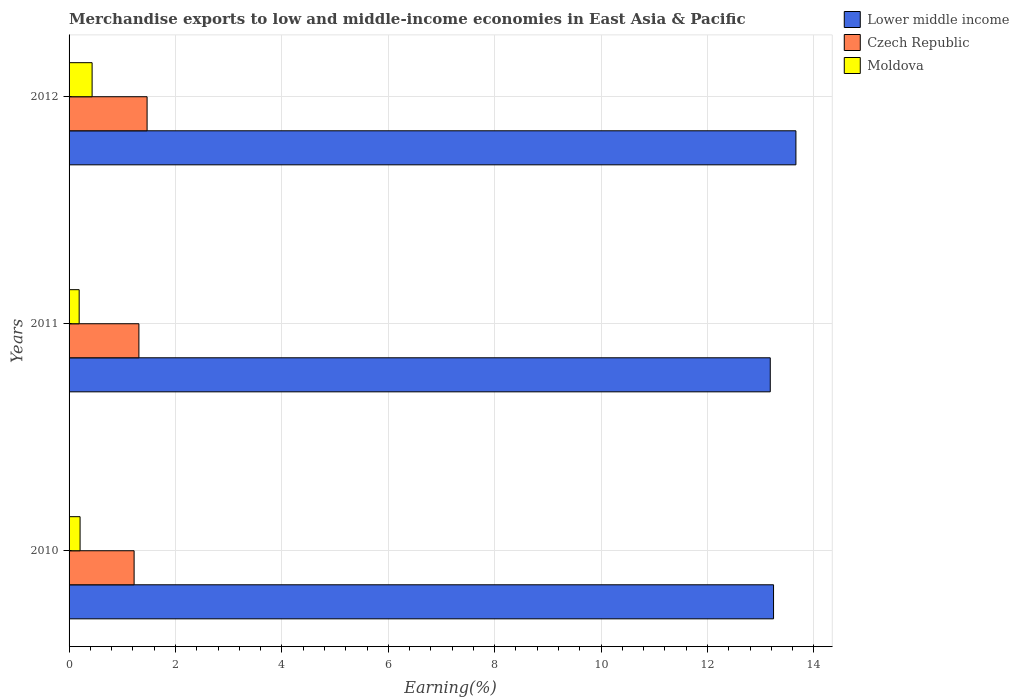How many different coloured bars are there?
Your response must be concise. 3. How many groups of bars are there?
Give a very brief answer. 3. How many bars are there on the 2nd tick from the top?
Provide a short and direct response. 3. How many bars are there on the 3rd tick from the bottom?
Ensure brevity in your answer.  3. In how many cases, is the number of bars for a given year not equal to the number of legend labels?
Give a very brief answer. 0. What is the percentage of amount earned from merchandise exports in Czech Republic in 2011?
Your response must be concise. 1.31. Across all years, what is the maximum percentage of amount earned from merchandise exports in Lower middle income?
Ensure brevity in your answer.  13.66. Across all years, what is the minimum percentage of amount earned from merchandise exports in Czech Republic?
Ensure brevity in your answer.  1.22. In which year was the percentage of amount earned from merchandise exports in Lower middle income minimum?
Give a very brief answer. 2011. What is the total percentage of amount earned from merchandise exports in Moldova in the graph?
Offer a very short reply. 0.83. What is the difference between the percentage of amount earned from merchandise exports in Czech Republic in 2010 and that in 2011?
Ensure brevity in your answer.  -0.09. What is the difference between the percentage of amount earned from merchandise exports in Lower middle income in 2010 and the percentage of amount earned from merchandise exports in Czech Republic in 2012?
Make the answer very short. 11.77. What is the average percentage of amount earned from merchandise exports in Czech Republic per year?
Offer a terse response. 1.33. In the year 2012, what is the difference between the percentage of amount earned from merchandise exports in Lower middle income and percentage of amount earned from merchandise exports in Czech Republic?
Ensure brevity in your answer.  12.19. In how many years, is the percentage of amount earned from merchandise exports in Czech Republic greater than 13.2 %?
Offer a very short reply. 0. What is the ratio of the percentage of amount earned from merchandise exports in Moldova in 2010 to that in 2012?
Keep it short and to the point. 0.48. Is the percentage of amount earned from merchandise exports in Lower middle income in 2010 less than that in 2012?
Offer a very short reply. Yes. Is the difference between the percentage of amount earned from merchandise exports in Lower middle income in 2010 and 2012 greater than the difference between the percentage of amount earned from merchandise exports in Czech Republic in 2010 and 2012?
Keep it short and to the point. No. What is the difference between the highest and the second highest percentage of amount earned from merchandise exports in Moldova?
Keep it short and to the point. 0.23. What is the difference between the highest and the lowest percentage of amount earned from merchandise exports in Moldova?
Ensure brevity in your answer.  0.24. What does the 3rd bar from the top in 2012 represents?
Provide a succinct answer. Lower middle income. What does the 2nd bar from the bottom in 2010 represents?
Your answer should be compact. Czech Republic. How many bars are there?
Make the answer very short. 9. How many years are there in the graph?
Provide a short and direct response. 3. Are the values on the major ticks of X-axis written in scientific E-notation?
Your answer should be compact. No. Does the graph contain any zero values?
Offer a very short reply. No. What is the title of the graph?
Make the answer very short. Merchandise exports to low and middle-income economies in East Asia & Pacific. Does "Malta" appear as one of the legend labels in the graph?
Ensure brevity in your answer.  No. What is the label or title of the X-axis?
Ensure brevity in your answer.  Earning(%). What is the label or title of the Y-axis?
Offer a terse response. Years. What is the Earning(%) in Lower middle income in 2010?
Ensure brevity in your answer.  13.24. What is the Earning(%) in Czech Republic in 2010?
Ensure brevity in your answer.  1.22. What is the Earning(%) in Moldova in 2010?
Your response must be concise. 0.21. What is the Earning(%) of Lower middle income in 2011?
Ensure brevity in your answer.  13.18. What is the Earning(%) of Czech Republic in 2011?
Offer a very short reply. 1.31. What is the Earning(%) in Moldova in 2011?
Give a very brief answer. 0.19. What is the Earning(%) in Lower middle income in 2012?
Your answer should be compact. 13.66. What is the Earning(%) of Czech Republic in 2012?
Your answer should be compact. 1.47. What is the Earning(%) of Moldova in 2012?
Ensure brevity in your answer.  0.43. Across all years, what is the maximum Earning(%) in Lower middle income?
Offer a very short reply. 13.66. Across all years, what is the maximum Earning(%) of Czech Republic?
Keep it short and to the point. 1.47. Across all years, what is the maximum Earning(%) in Moldova?
Keep it short and to the point. 0.43. Across all years, what is the minimum Earning(%) of Lower middle income?
Make the answer very short. 13.18. Across all years, what is the minimum Earning(%) of Czech Republic?
Offer a very short reply. 1.22. Across all years, what is the minimum Earning(%) of Moldova?
Give a very brief answer. 0.19. What is the total Earning(%) in Lower middle income in the graph?
Offer a very short reply. 40.08. What is the total Earning(%) in Czech Republic in the graph?
Make the answer very short. 4. What is the total Earning(%) in Moldova in the graph?
Your answer should be very brief. 0.83. What is the difference between the Earning(%) of Lower middle income in 2010 and that in 2011?
Ensure brevity in your answer.  0.06. What is the difference between the Earning(%) in Czech Republic in 2010 and that in 2011?
Your answer should be compact. -0.09. What is the difference between the Earning(%) of Moldova in 2010 and that in 2011?
Give a very brief answer. 0.02. What is the difference between the Earning(%) in Lower middle income in 2010 and that in 2012?
Keep it short and to the point. -0.42. What is the difference between the Earning(%) of Czech Republic in 2010 and that in 2012?
Make the answer very short. -0.24. What is the difference between the Earning(%) in Moldova in 2010 and that in 2012?
Your answer should be very brief. -0.23. What is the difference between the Earning(%) of Lower middle income in 2011 and that in 2012?
Provide a succinct answer. -0.48. What is the difference between the Earning(%) in Czech Republic in 2011 and that in 2012?
Make the answer very short. -0.15. What is the difference between the Earning(%) of Moldova in 2011 and that in 2012?
Provide a succinct answer. -0.24. What is the difference between the Earning(%) in Lower middle income in 2010 and the Earning(%) in Czech Republic in 2011?
Keep it short and to the point. 11.93. What is the difference between the Earning(%) of Lower middle income in 2010 and the Earning(%) of Moldova in 2011?
Ensure brevity in your answer.  13.05. What is the difference between the Earning(%) in Czech Republic in 2010 and the Earning(%) in Moldova in 2011?
Provide a succinct answer. 1.03. What is the difference between the Earning(%) in Lower middle income in 2010 and the Earning(%) in Czech Republic in 2012?
Ensure brevity in your answer.  11.77. What is the difference between the Earning(%) in Lower middle income in 2010 and the Earning(%) in Moldova in 2012?
Give a very brief answer. 12.81. What is the difference between the Earning(%) in Czech Republic in 2010 and the Earning(%) in Moldova in 2012?
Provide a succinct answer. 0.79. What is the difference between the Earning(%) of Lower middle income in 2011 and the Earning(%) of Czech Republic in 2012?
Provide a short and direct response. 11.71. What is the difference between the Earning(%) in Lower middle income in 2011 and the Earning(%) in Moldova in 2012?
Make the answer very short. 12.75. What is the difference between the Earning(%) of Czech Republic in 2011 and the Earning(%) of Moldova in 2012?
Ensure brevity in your answer.  0.88. What is the average Earning(%) in Lower middle income per year?
Your answer should be compact. 13.36. What is the average Earning(%) of Czech Republic per year?
Offer a very short reply. 1.33. What is the average Earning(%) of Moldova per year?
Offer a terse response. 0.28. In the year 2010, what is the difference between the Earning(%) in Lower middle income and Earning(%) in Czech Republic?
Your answer should be very brief. 12.02. In the year 2010, what is the difference between the Earning(%) of Lower middle income and Earning(%) of Moldova?
Provide a succinct answer. 13.03. In the year 2010, what is the difference between the Earning(%) of Czech Republic and Earning(%) of Moldova?
Your answer should be compact. 1.02. In the year 2011, what is the difference between the Earning(%) of Lower middle income and Earning(%) of Czech Republic?
Offer a very short reply. 11.87. In the year 2011, what is the difference between the Earning(%) in Lower middle income and Earning(%) in Moldova?
Offer a very short reply. 12.99. In the year 2011, what is the difference between the Earning(%) of Czech Republic and Earning(%) of Moldova?
Ensure brevity in your answer.  1.12. In the year 2012, what is the difference between the Earning(%) of Lower middle income and Earning(%) of Czech Republic?
Provide a succinct answer. 12.19. In the year 2012, what is the difference between the Earning(%) of Lower middle income and Earning(%) of Moldova?
Offer a terse response. 13.23. In the year 2012, what is the difference between the Earning(%) of Czech Republic and Earning(%) of Moldova?
Your answer should be very brief. 1.03. What is the ratio of the Earning(%) of Lower middle income in 2010 to that in 2011?
Provide a succinct answer. 1. What is the ratio of the Earning(%) of Czech Republic in 2010 to that in 2011?
Provide a short and direct response. 0.93. What is the ratio of the Earning(%) of Moldova in 2010 to that in 2011?
Your response must be concise. 1.09. What is the ratio of the Earning(%) in Lower middle income in 2010 to that in 2012?
Provide a succinct answer. 0.97. What is the ratio of the Earning(%) of Czech Republic in 2010 to that in 2012?
Give a very brief answer. 0.83. What is the ratio of the Earning(%) of Moldova in 2010 to that in 2012?
Your answer should be very brief. 0.48. What is the ratio of the Earning(%) of Lower middle income in 2011 to that in 2012?
Your response must be concise. 0.96. What is the ratio of the Earning(%) of Czech Republic in 2011 to that in 2012?
Your response must be concise. 0.9. What is the ratio of the Earning(%) of Moldova in 2011 to that in 2012?
Ensure brevity in your answer.  0.44. What is the difference between the highest and the second highest Earning(%) of Lower middle income?
Provide a short and direct response. 0.42. What is the difference between the highest and the second highest Earning(%) in Czech Republic?
Make the answer very short. 0.15. What is the difference between the highest and the second highest Earning(%) in Moldova?
Make the answer very short. 0.23. What is the difference between the highest and the lowest Earning(%) in Lower middle income?
Provide a short and direct response. 0.48. What is the difference between the highest and the lowest Earning(%) in Czech Republic?
Make the answer very short. 0.24. What is the difference between the highest and the lowest Earning(%) of Moldova?
Provide a succinct answer. 0.24. 